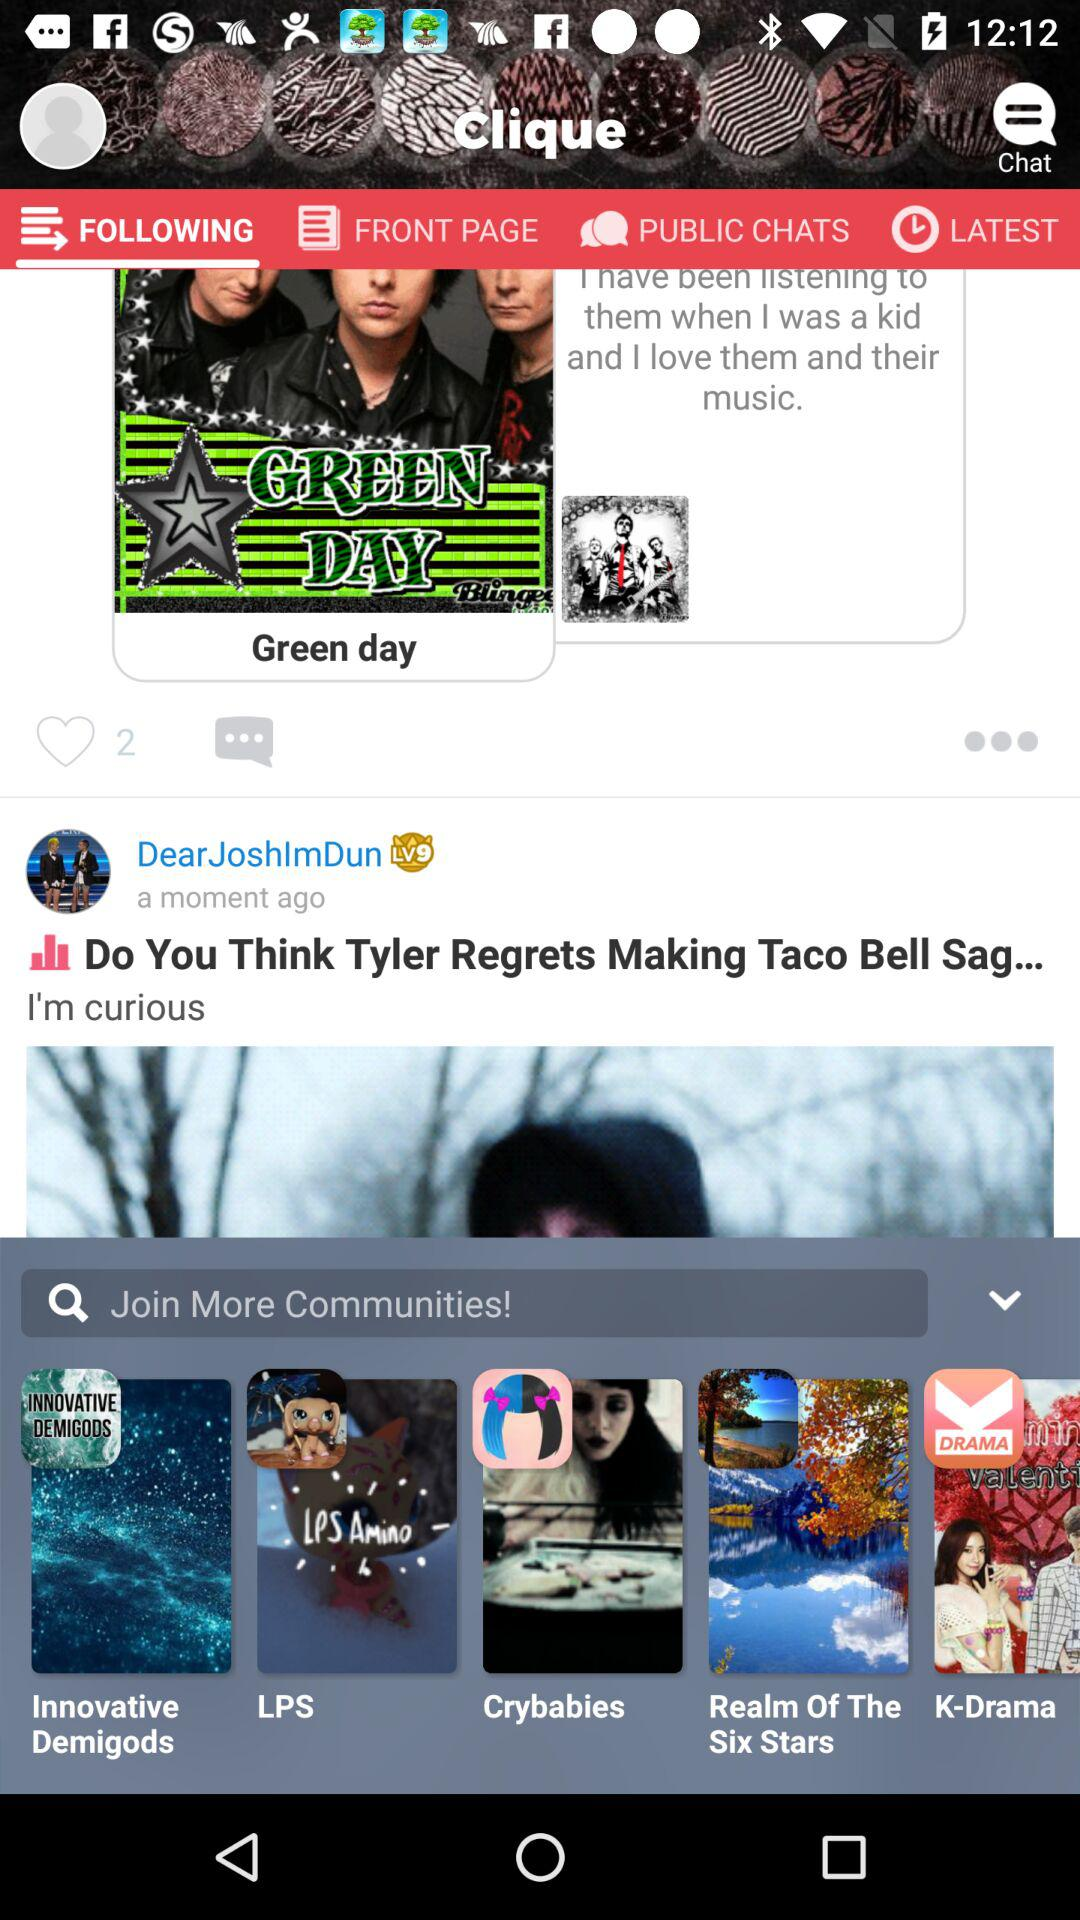What is the username? The username is "DearJoshImDun". 